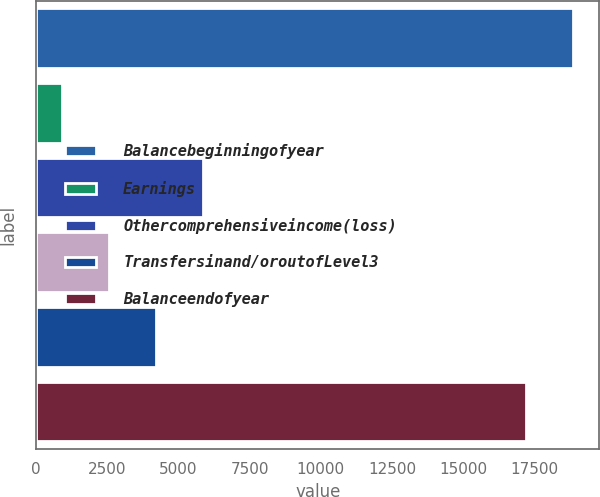<chart> <loc_0><loc_0><loc_500><loc_500><bar_chart><fcel>Balancebeginningofyear<fcel>Earnings<fcel>Othercomprehensiveincome(loss)<fcel>Unnamed: 3<fcel>Transfersinand/oroutofLevel3<fcel>Balanceendofyear<nl><fcel>18838.4<fcel>924<fcel>5869.2<fcel>2572.4<fcel>4220.8<fcel>17190<nl></chart> 